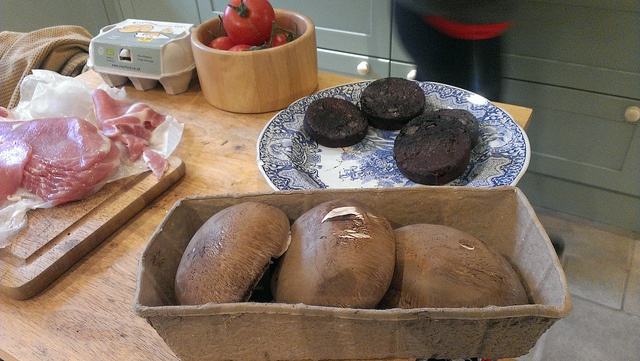Describe the objects in this image and their specific colors. I can see bowl in gray, maroon, and darkgray tones, dining table in gray and tan tones, bowl in gray, brown, tan, and maroon tones, cake in gray and black tones, and cake in gray and black tones in this image. 